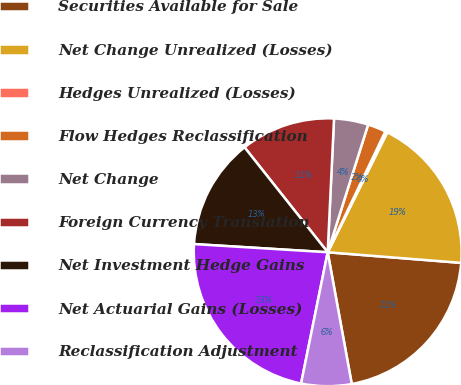Convert chart. <chart><loc_0><loc_0><loc_500><loc_500><pie_chart><fcel>Securities Available for Sale<fcel>Net Change Unrealized (Losses)<fcel>Hedges Unrealized (Losses)<fcel>Flow Hedges Reclassification<fcel>Net Change<fcel>Foreign Currency Translation<fcel>Net Investment Hedge Gains<fcel>Net Actuarial Gains (Losses)<fcel>Reclassification Adjustment<nl><fcel>20.86%<fcel>18.92%<fcel>0.26%<fcel>2.2%<fcel>4.13%<fcel>11.42%<fcel>13.36%<fcel>22.79%<fcel>6.06%<nl></chart> 